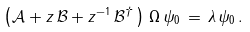<formula> <loc_0><loc_0><loc_500><loc_500>\left ( \mathcal { A } + z \, \mathcal { B } + z ^ { - 1 } \, \mathcal { B } ^ { \dagger } \, \right ) \, \Omega \, \psi _ { 0 } \, = \, \lambda \, \psi _ { 0 } \, .</formula> 